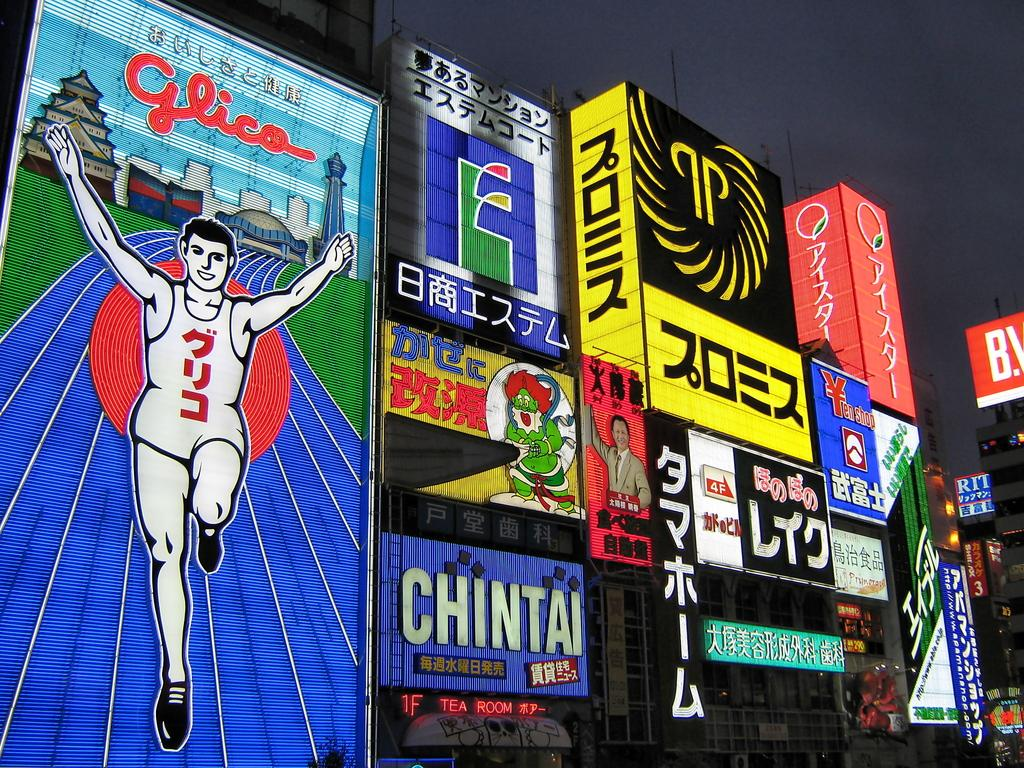<image>
Write a terse but informative summary of the picture. A bunch of billboard with the one in the middle having the word Chintai on it 